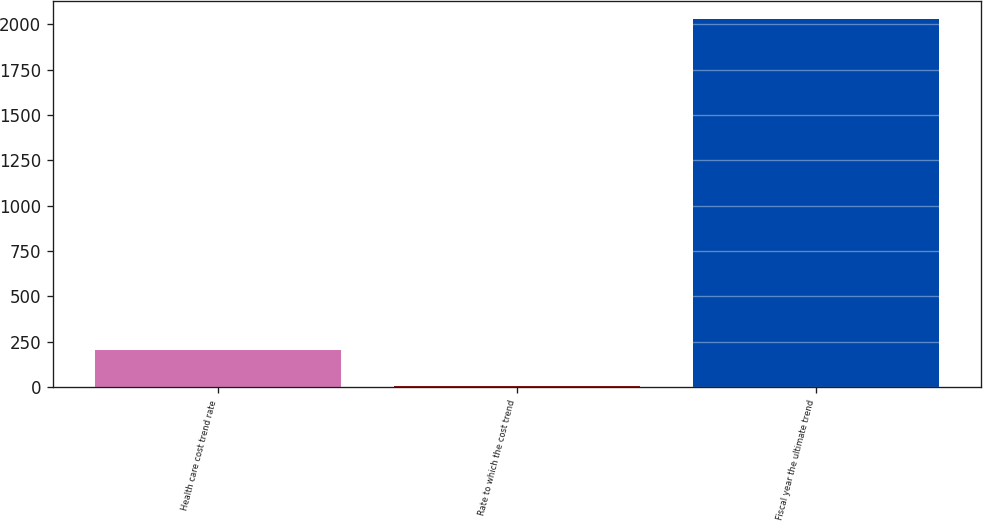Convert chart. <chart><loc_0><loc_0><loc_500><loc_500><bar_chart><fcel>Health care cost trend rate<fcel>Rate to which the cost trend<fcel>Fiscal year the ultimate trend<nl><fcel>206.95<fcel>4.5<fcel>2029<nl></chart> 